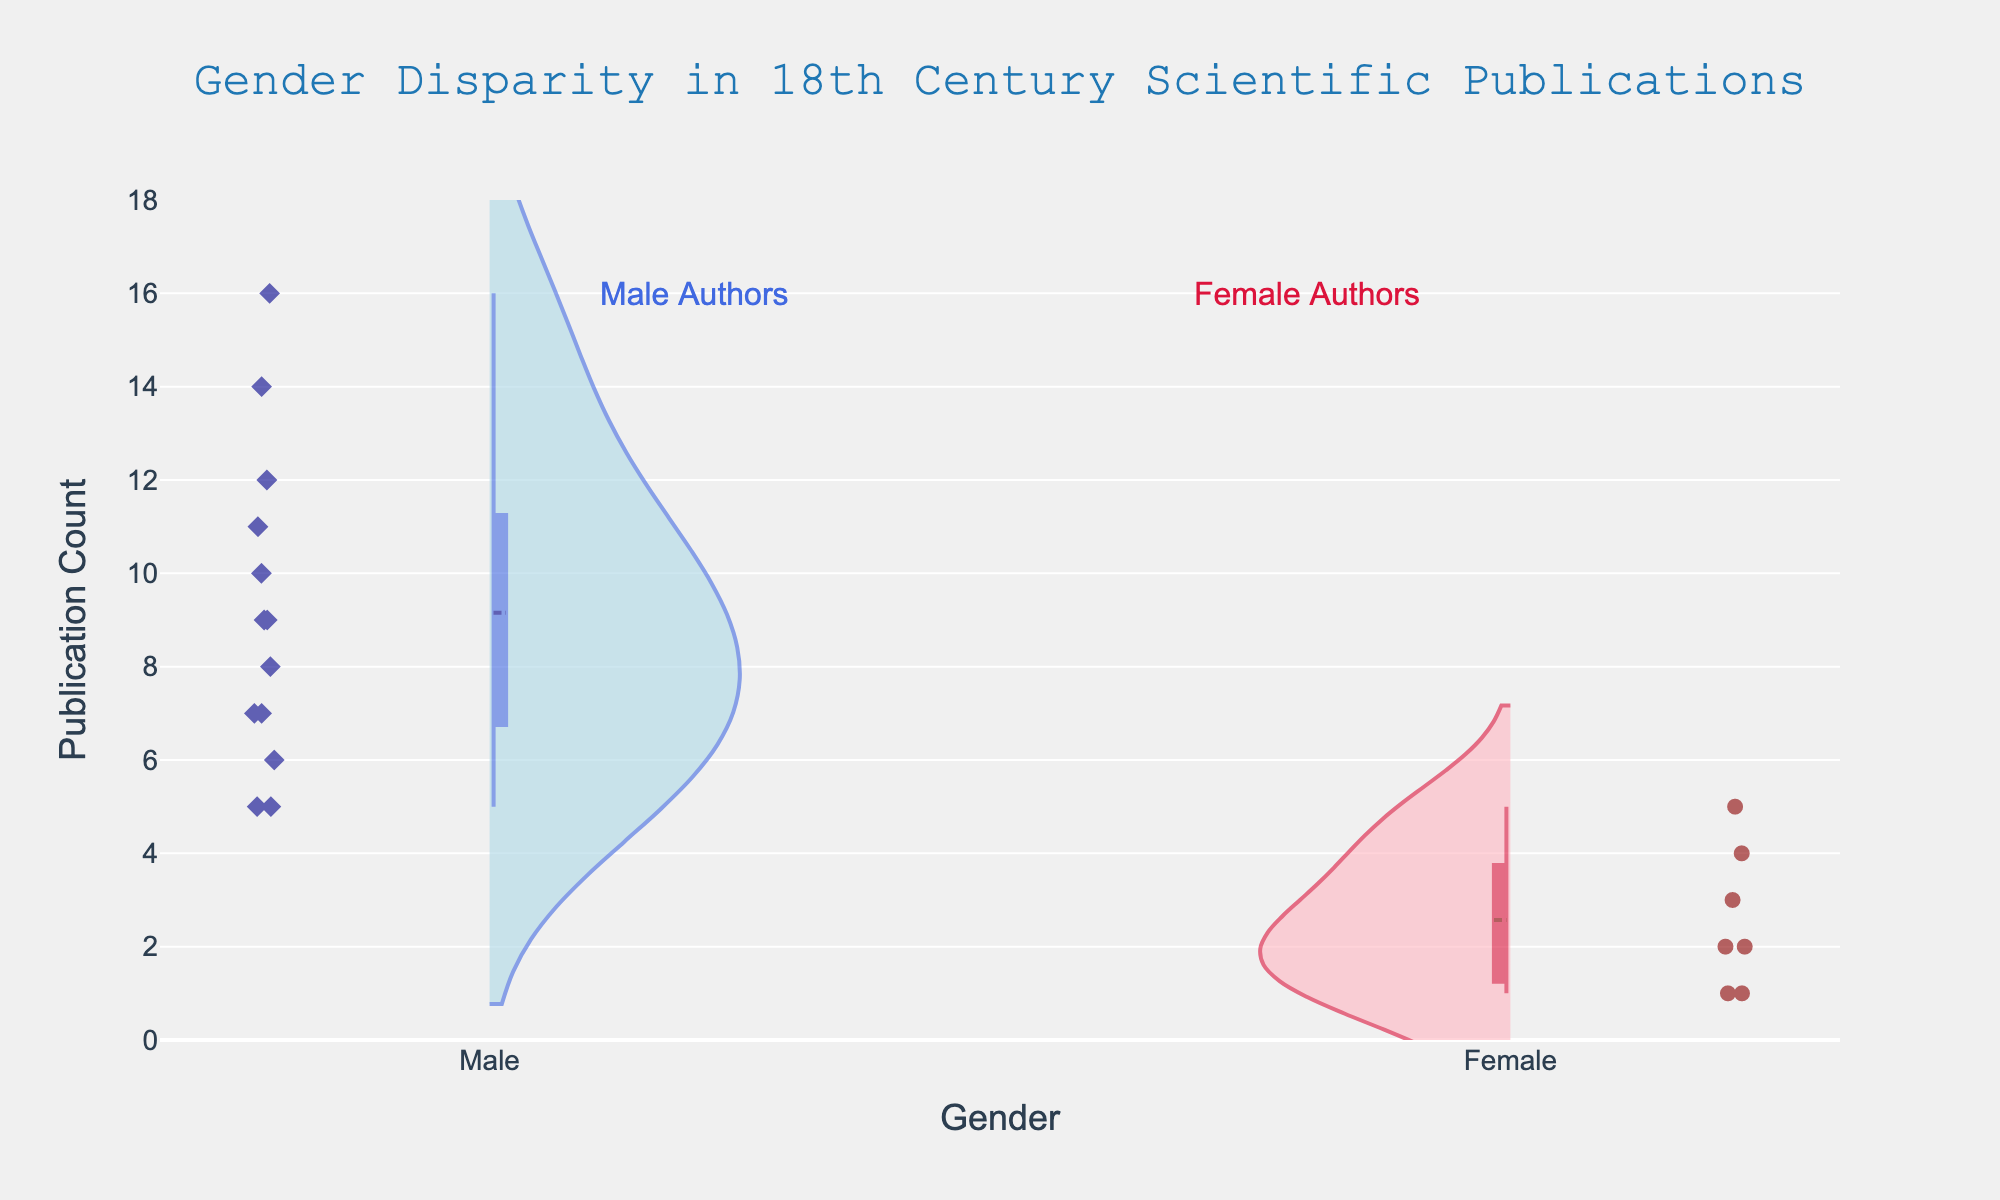What is the title of the plot? The plot title text is directly located above the figure and reads "Gender Disparity in 18th Century Scientific Publications".
Answer: Gender Disparity in 18th Century Scientific Publications What is the y-axis range in the plot? The y-axis range is labeled on the vertical axis with values starting from 0 up to 18. This range is clearly indicated by the ticks on the y-axis.
Answer: 0 to 18 How many publication counts did the male authors have on average? To determine this, sum up the publication counts for all male authors and then divide by the number of male authors. The publication counts are (14 + 16 + 12 + 10 + 9 + 6 + 8 + 5 + 7 + 7 + 9 + 5 + 11). The sum is 119, and there are 13 male authors. The average is 119 / 13 ≈ 9.15.
Answer: 9.15 Which gender had the highest individual publication count, and what was that count? On the figure, the highest individual publication count can be identified by checking the farthest point on the y-axis for each gender. For male authors, the highest is 16, and for female authors, the highest is 5. Therefore, the highest individual publication count is 16, and it belongs to a male author.
Answer: Male, 16 How many female authors had more than one publication? By checking the female authors' marks within the plotted points on the left side (negative side), we can count the number of data points above the value of 1 on the y-axis. These are 2 (Mary Wollstonecraft), 3 (Dorothea Erxleben), and 4 (Caroline Herschel). Therefore, 3 female authors had more than one publication.
Answer: 3 Which group had more variability in publication counts? Variability can be assessed visually by observing the spread of the points and the width of the violin plots. The male authors' plot shows a wider spread from 5 to 16, while female authors range from 1 to 5. Thus, the male authors exhibit more variability in publication counts.
Answer: Male What is the median publication count for female authors? The median is the middle value when the publication counts are ordered. The counts for female authors are (1, 1, 2, 3, 4, 5). The median, being the middle number in 1, 2, 3, and 4, 5, 6, is 2.5, but since we actually have a clear middle data point, it's clear that 2 is the median.
Answer: 2 Compare the spread and central tendency of both groups. The spread for males is 5 to 16, while females' range is 1 to 5. The central tendency or average for males is around 9.15, whereas for females, the publication counts are skewed lower, and the median is 2. The wider spread and higher central value indicate higher publication counts among males.
Answer: Males have a wider range and higher median How does the shape of the violin plots inform us about gender disparities? The negative side (female) is much narrower and skewed towards lower publication counts, showing fewer publications by females. The positive side (male) is both wider and reaches much higher, indicating a higher number of publications and greater variability among male authors. The shape difference portrays a clear gender disparity in publications.
Answer: Males show greater variability and higher counts than females 